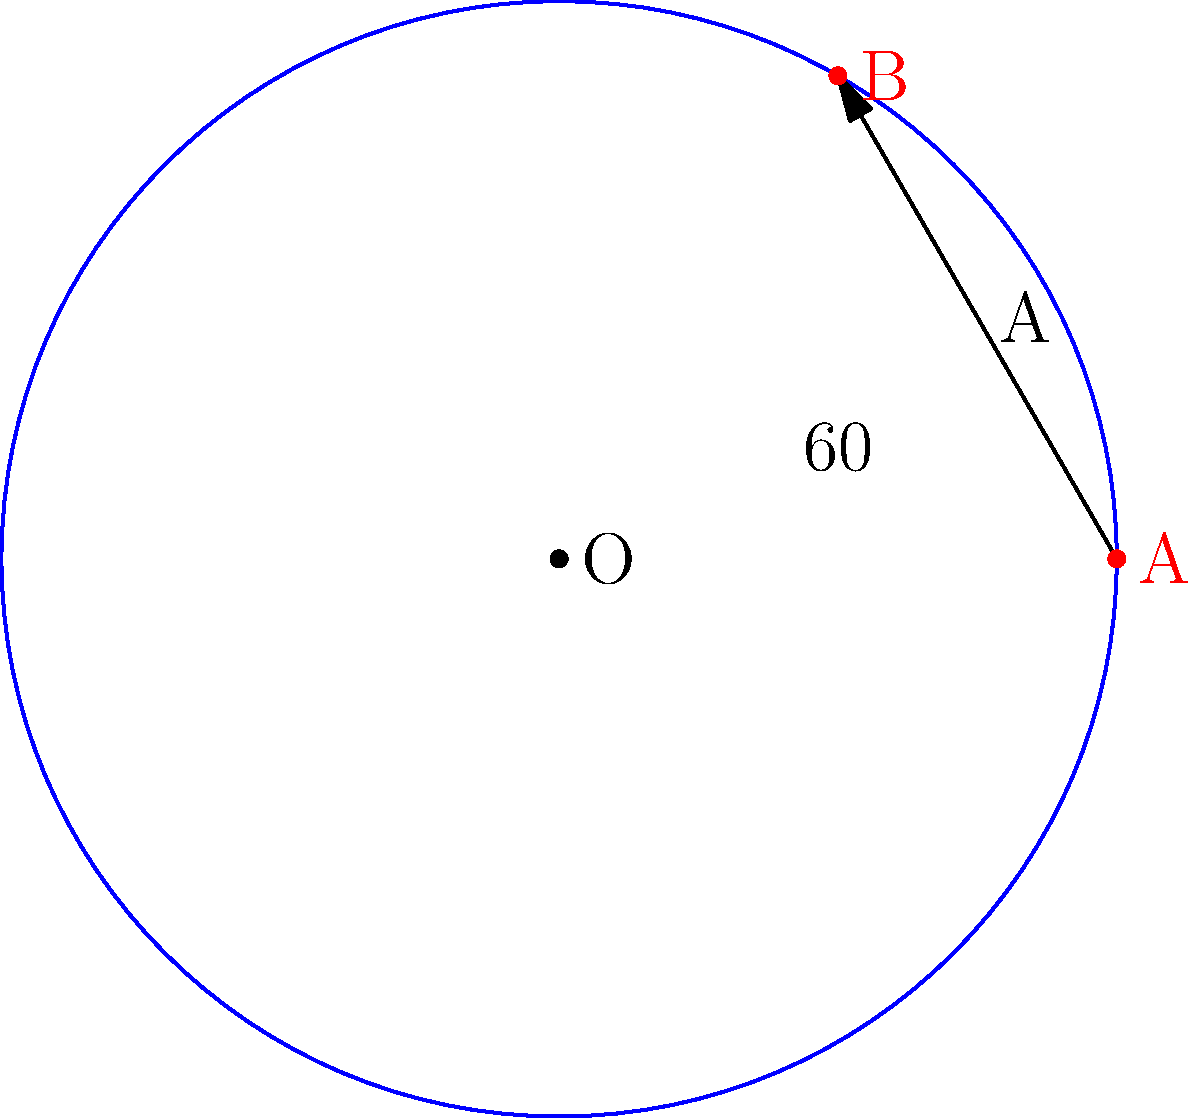As the class president, you're tasked with optimizing the placement of new facilities on your circular school property. The property has a radius of 100 meters, and you need to place two new buildings: a library (A) and a cafeteria (B). The library is located at $(100, 0)$ in polar coordinates, and you want to place the cafeteria so that the angle between them is 60°. What are the polar coordinates $(r, \theta)$ of the cafeteria? Let's approach this step-by-step:

1) The school property is circular with a radius of 100 meters.

2) The library (A) is located at $(100, 0)$ in polar coordinates. This means it's on the positive x-axis, 100 meters from the center.

3) We need to place the cafeteria (B) so that the angle between A and B is 60°.

4) In polar coordinates, the angle is measured counterclockwise from the positive x-axis. So, the angle for point B will be 60° or $\frac{\pi}{3}$ radians.

5) The radius for point B will be the same as point A, which is 100 meters, because both buildings are on the edge of the circular property.

6) Therefore, the polar coordinates of the cafeteria (B) will be:
   $r = 100$ (radius)
   $\theta = \frac{\pi}{3}$ or 60° (angle)

7) In polar coordinate notation, this is written as $(100, \frac{\pi}{3})$ or $(100, 60°)$.
Answer: $(100, \frac{\pi}{3})$ 